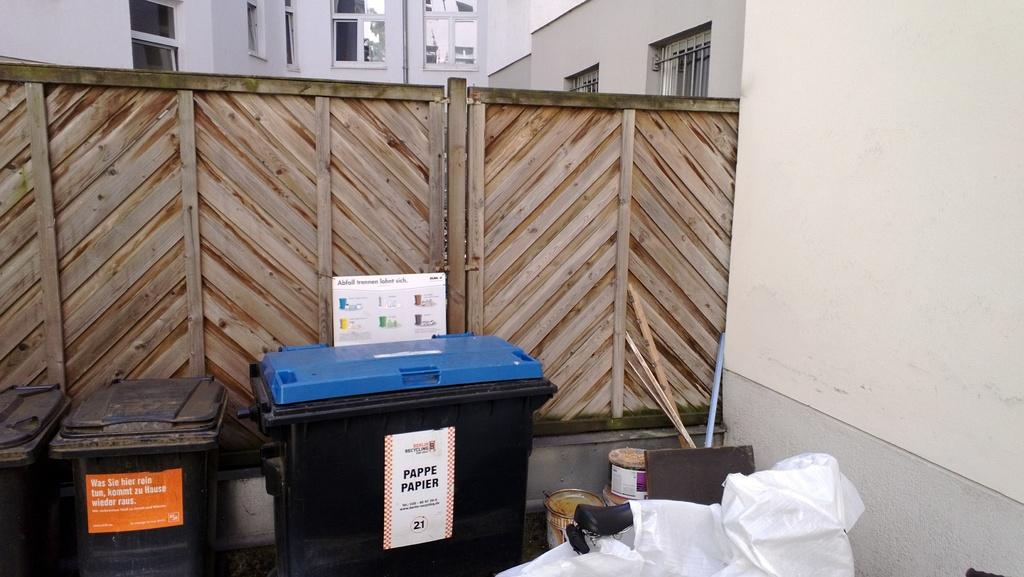<image>
Describe the image concisely. Several waste bins lined up near a fence and next to a pappe papier bin. 